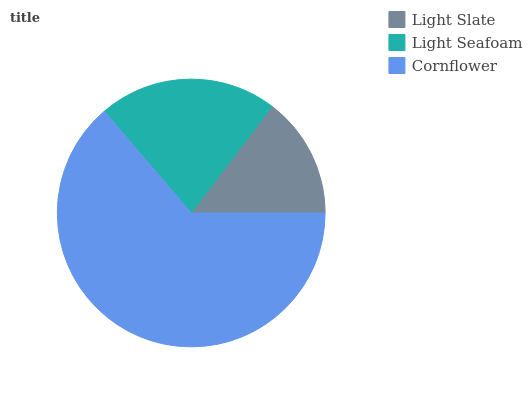Is Light Slate the minimum?
Answer yes or no. Yes. Is Cornflower the maximum?
Answer yes or no. Yes. Is Light Seafoam the minimum?
Answer yes or no. No. Is Light Seafoam the maximum?
Answer yes or no. No. Is Light Seafoam greater than Light Slate?
Answer yes or no. Yes. Is Light Slate less than Light Seafoam?
Answer yes or no. Yes. Is Light Slate greater than Light Seafoam?
Answer yes or no. No. Is Light Seafoam less than Light Slate?
Answer yes or no. No. Is Light Seafoam the high median?
Answer yes or no. Yes. Is Light Seafoam the low median?
Answer yes or no. Yes. Is Cornflower the high median?
Answer yes or no. No. Is Cornflower the low median?
Answer yes or no. No. 